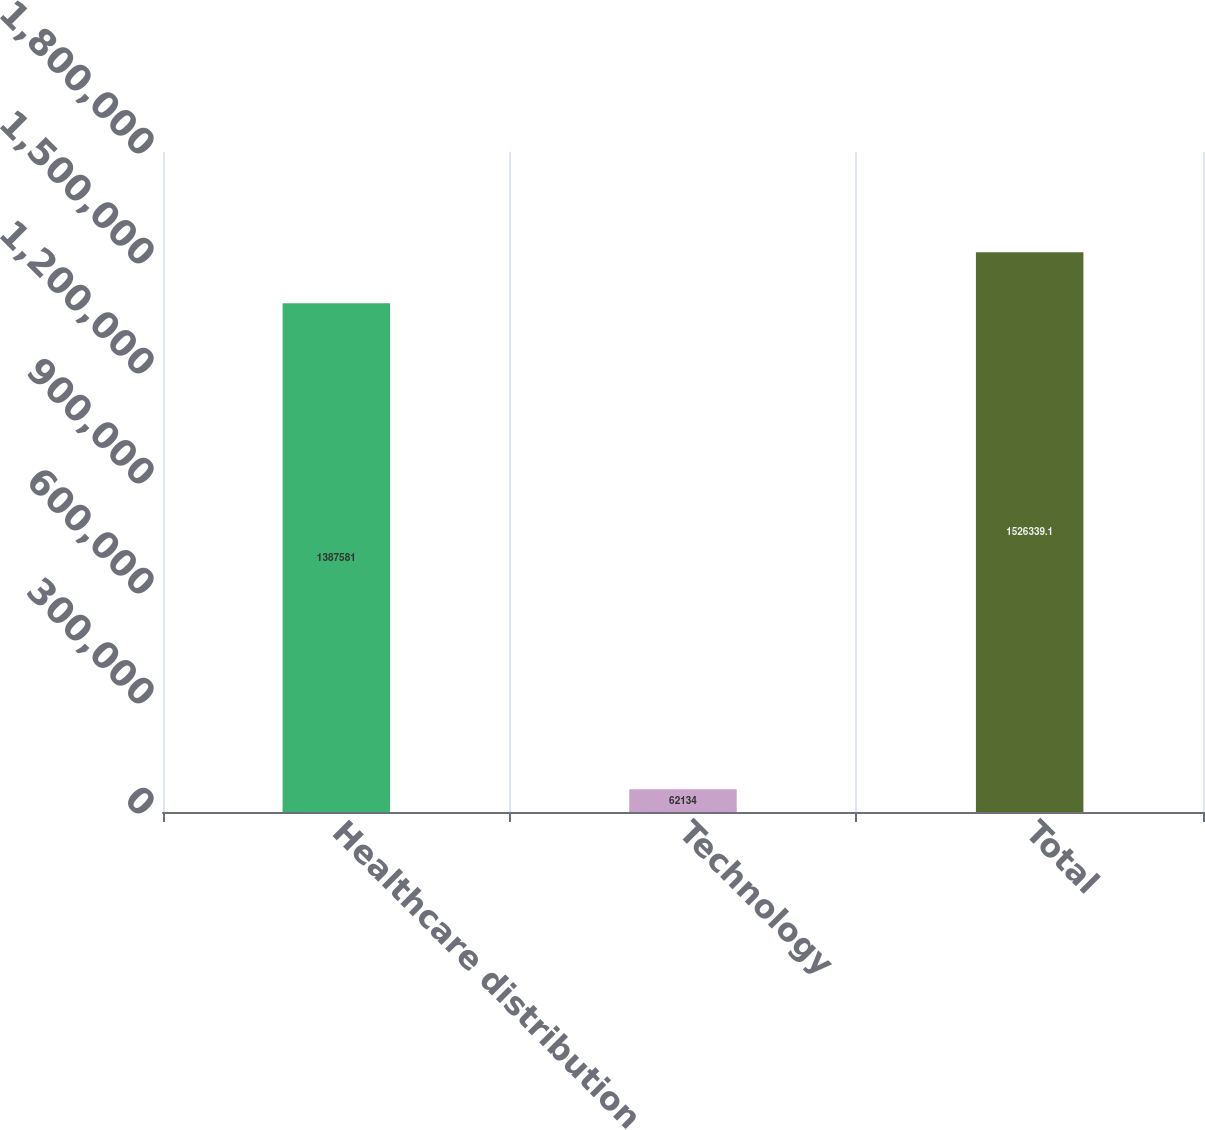Convert chart to OTSL. <chart><loc_0><loc_0><loc_500><loc_500><bar_chart><fcel>Healthcare distribution<fcel>Technology<fcel>Total<nl><fcel>1.38758e+06<fcel>62134<fcel>1.52634e+06<nl></chart> 